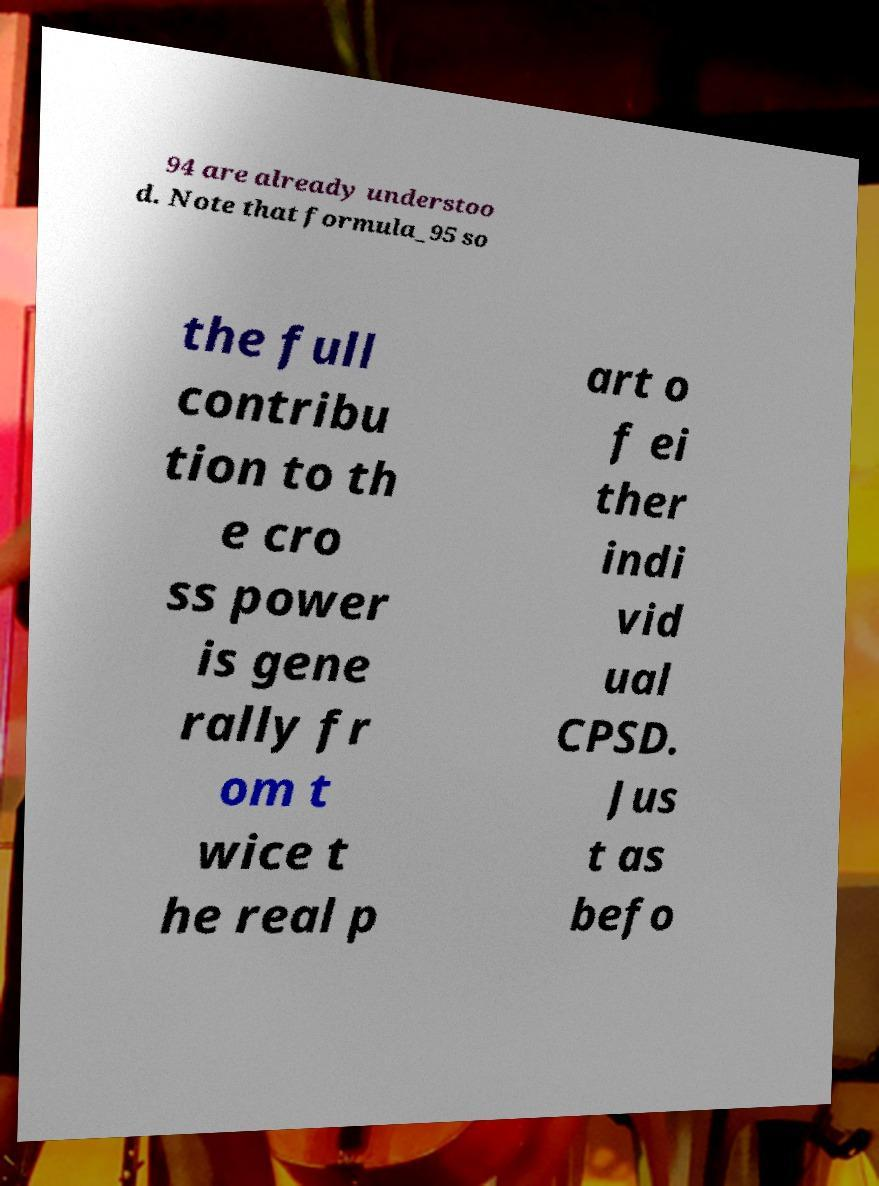Please identify and transcribe the text found in this image. 94 are already understoo d. Note that formula_95 so the full contribu tion to th e cro ss power is gene rally fr om t wice t he real p art o f ei ther indi vid ual CPSD. Jus t as befo 